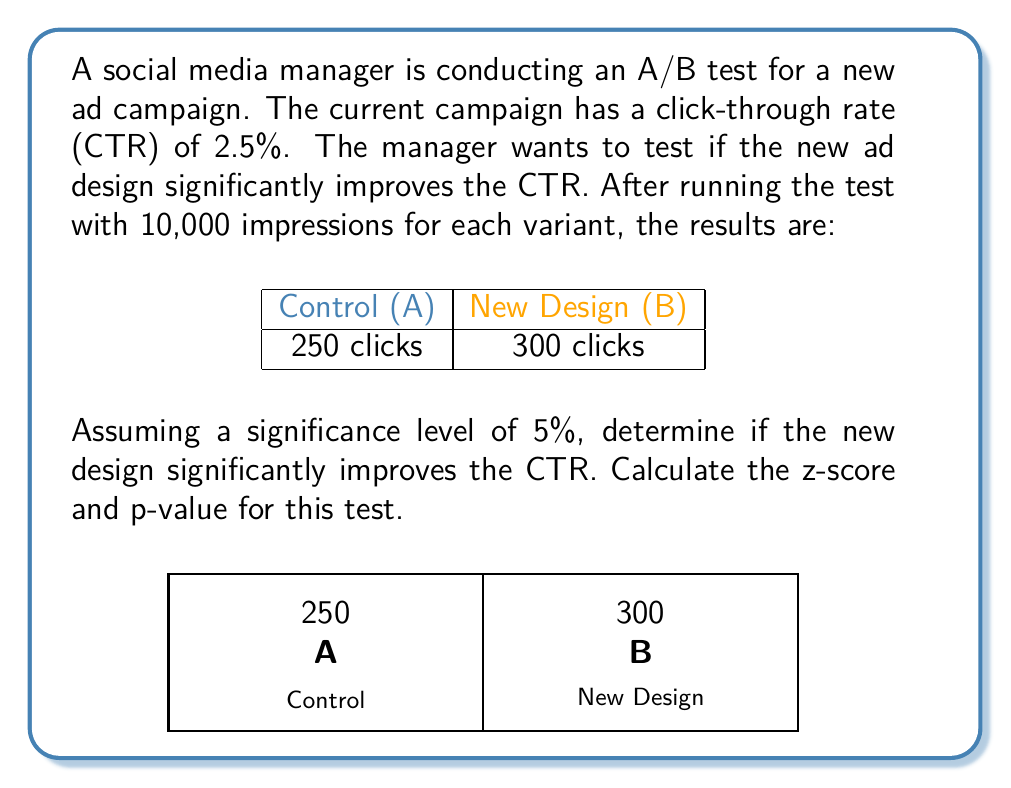Provide a solution to this math problem. To determine if the new design significantly improves the CTR, we'll use a one-tailed z-test for proportions.

Step 1: State the null and alternative hypotheses
$H_0: p_B - p_A = 0$
$H_a: p_B - p_A > 0$

Step 2: Calculate the pooled proportion
$$p = \frac{x_A + x_B}{n_A + n_B} = \frac{250 + 300}{10000 + 10000} = 0.0275$$

Step 3: Calculate the standard error
$$SE = \sqrt{p(1-p)(\frac{1}{n_A} + \frac{1}{n_B})} = \sqrt{0.0275(1-0.0275)(\frac{1}{10000} + \frac{1}{10000})} = 0.002316$$

Step 4: Calculate the z-score
$$z = \frac{(p_B - p_A) - 0}{SE} = \frac{(\frac{300}{10000} - \frac{250}{10000}) - 0}{0.002316} = 2.1588$$

Step 5: Calculate the p-value
Using a standard normal distribution table or calculator, we find:
$$p\text{-value} = P(Z > 2.1588) = 0.0154$$

Step 6: Compare the p-value to the significance level
Since $0.0154 < 0.05$, we reject the null hypothesis.
Answer: z-score: 2.1588, p-value: 0.0154. The new design significantly improves CTR. 